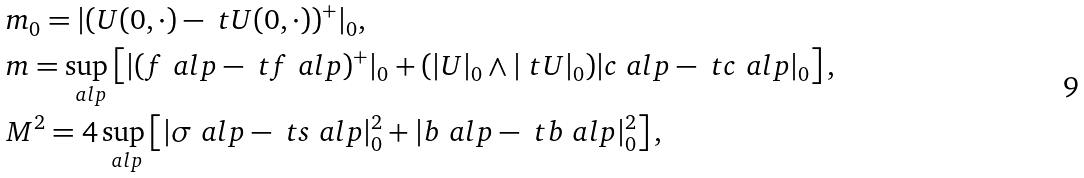<formula> <loc_0><loc_0><loc_500><loc_500>& m _ { 0 } = | ( U ( 0 , \cdot ) - \ t U ( 0 , \cdot ) ) ^ { + } | _ { 0 } , \\ & m = \sup _ { \ a l p } \left [ | ( f ^ { \ } a l p - \ t f ^ { \ } a l p ) ^ { + } | _ { 0 } + ( | U | _ { 0 } \wedge | \ t U | _ { 0 } ) | c ^ { \ } a l p - \ t c ^ { \ } a l p | _ { 0 } \right ] , \\ & M ^ { 2 } = 4 \sup _ { \ a l p } \left [ | \sigma ^ { \ } a l p - \ t s ^ { \ } a l p | _ { 0 } ^ { 2 } + | b ^ { \ } a l p - \ t b ^ { \ } a l p | _ { 0 } ^ { 2 } \right ] ,</formula> 